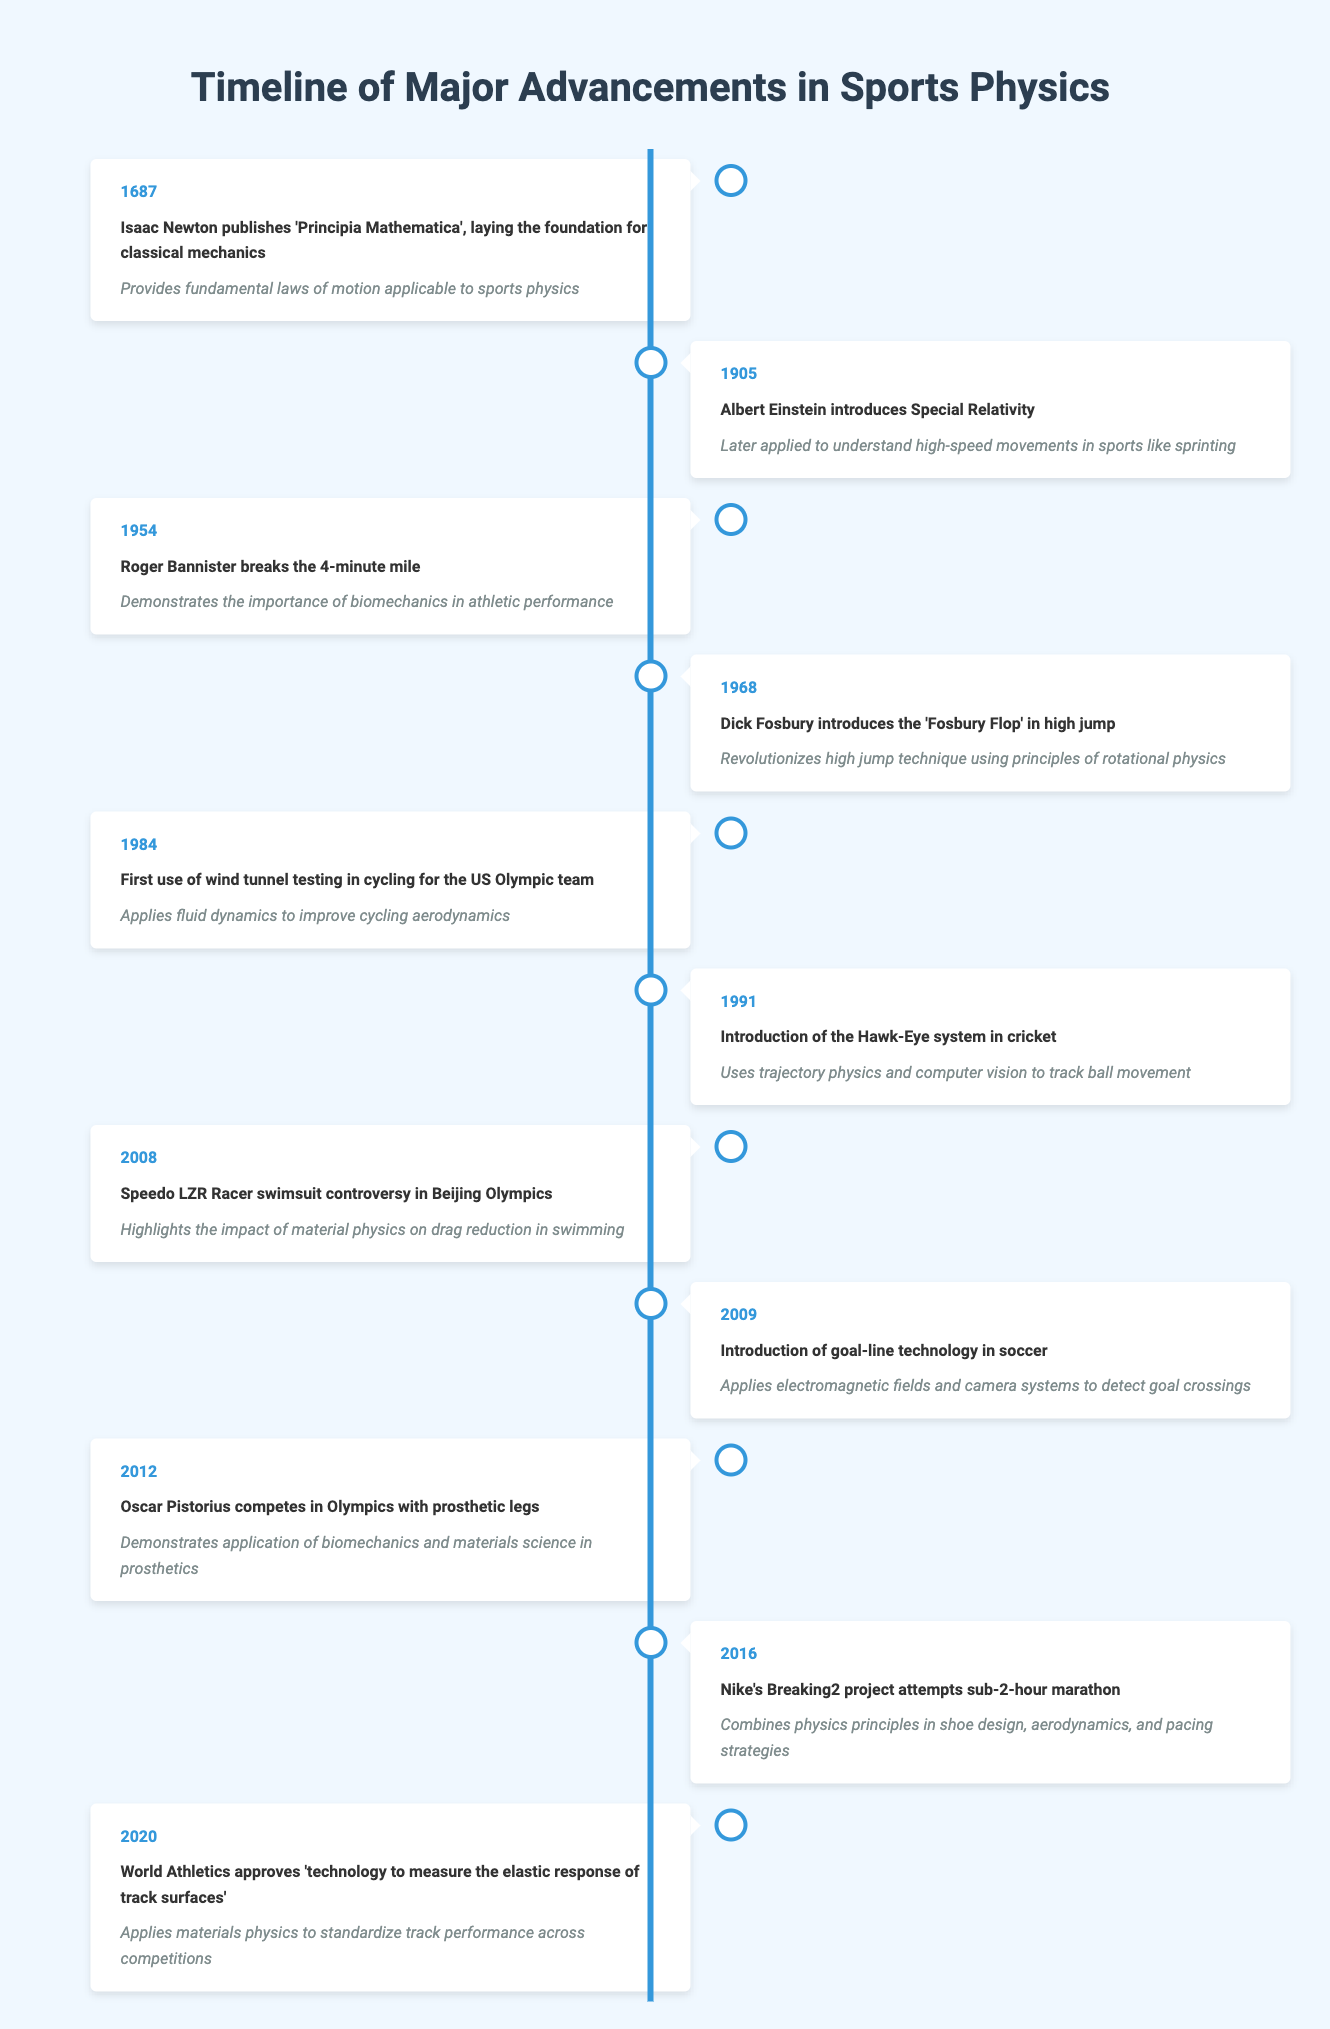What year did Isaac Newton publish 'Principia Mathematica'? The table indicates that Isaac Newton published 'Principia Mathematica' in the year 1687, which is explicitly stated in the first entry of the timeline.
Answer: 1687 What event occurred in 2009? According to the table, in 2009 the introduction of goal-line technology in soccer took place. This event is highlighted in a dedicated cell for the year 2009.
Answer: Introduction of goal-line technology in soccer Which event is associated with the significance related to biomechanics? The table presents two events related to biomechanics, but the one that most directly demonstrates its importance in athletic performance is Roger Bannister breaking the 4-minute mile in 1954. This significance is specifically noted in that entry.
Answer: Roger Bannister breaks the 4-minute mile True or False: The Speedo LZR Racer swimsuit controversy occurred before the introduction of goal-line technology in soccer. The timeline shows that the Speedo LZR Racer swimsuit controversy took place in 2008, while goal-line technology was introduced in 2009. This establishes the sequence of events, making the statement true.
Answer: True What is the difference in years between the introduction of the Hawk-Eye system and the Speedo LZR Racer swimsuit controversy? The Hawk-Eye system in cricket was introduced in 1991, and the Speedo LZR Racer swimsuit controversy occurred in 2008. To find the difference, subtract 1991 from 2008, which gives us 17 years.
Answer: 17 years In which year did Oscar Pistorius compete in the Olympics with prosthetic legs? The table states that Oscar Pistorius competed in the Olympics with prosthetic legs in 2012, as mentioned in that entry of the timeline.
Answer: 2012 What is the average year of the events from 1954 to 2016 included in the timeline? To find the average year of the events from 1954 to 2016, first, we note the years involved (1954, 1968, 1984, 1991, 2008, 2009, 2012, 2016), which totals to 8 events. The sum of these years is 1954 + 1968 + 1984 + 1991 + 2008 + 2009 + 2012 + 2016 = 15642. Dividing by 8 gives us an average year of 1954.25, which we round to 2010.
Answer: 2010 Did the event related to Nike's Breaking2 project involve principles in shoe design? The entry for the Nike's Breaking2 project from 2016 specifically mentions combining physics principles in shoe design, along with aerodynamics and pacing strategies. This indicates a clear yes, supporting the fact.
Answer: Yes Which event showed the application of materials physics to standardize track performance? The event in 2020, which refers to World Athletics approving technology to measure the elastic response of track surfaces, directly indicates the application of materials physics to standardize track performance across competitions.
Answer: World Athletics approves technology to measure the elastic response of track surfaces 